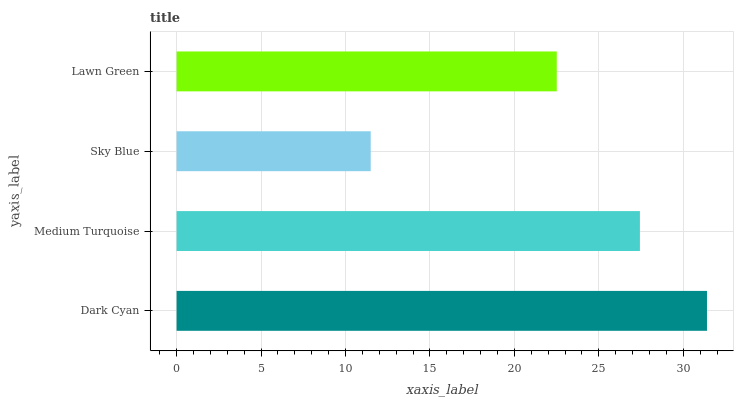Is Sky Blue the minimum?
Answer yes or no. Yes. Is Dark Cyan the maximum?
Answer yes or no. Yes. Is Medium Turquoise the minimum?
Answer yes or no. No. Is Medium Turquoise the maximum?
Answer yes or no. No. Is Dark Cyan greater than Medium Turquoise?
Answer yes or no. Yes. Is Medium Turquoise less than Dark Cyan?
Answer yes or no. Yes. Is Medium Turquoise greater than Dark Cyan?
Answer yes or no. No. Is Dark Cyan less than Medium Turquoise?
Answer yes or no. No. Is Medium Turquoise the high median?
Answer yes or no. Yes. Is Lawn Green the low median?
Answer yes or no. Yes. Is Lawn Green the high median?
Answer yes or no. No. Is Medium Turquoise the low median?
Answer yes or no. No. 